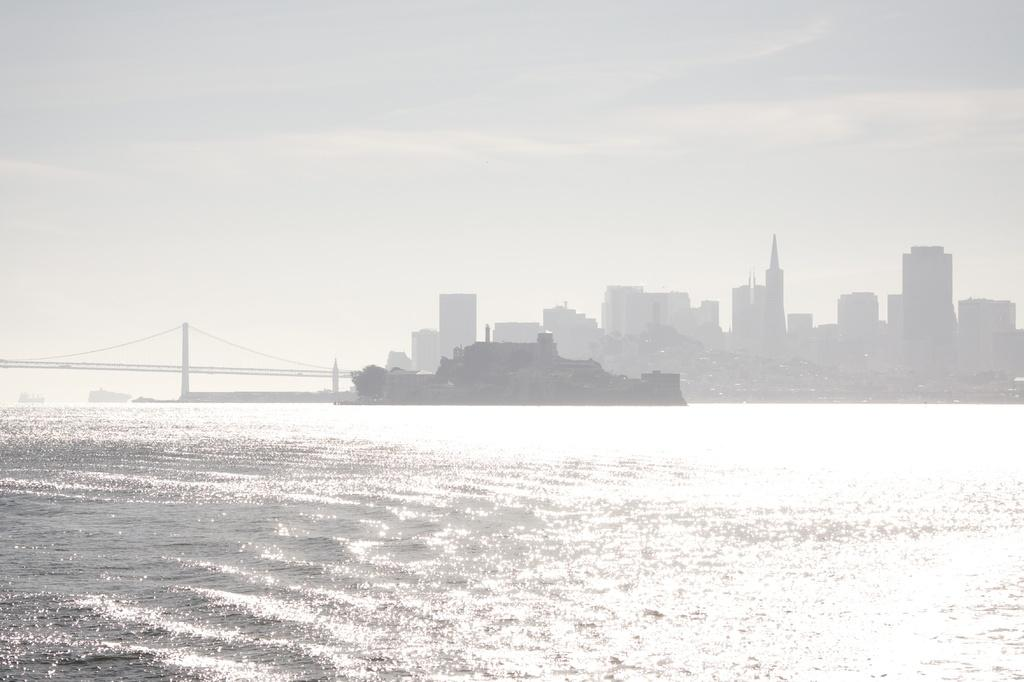What is the main subject of the image? There is a ship in the image. Where is the ship located? The ship is on the water. What can be seen in the background of the image? There is a bridge, buildings, a tree, and the sky visible in the background of the image. How many cherries are hanging from the tree in the image? There is no tree with cherries present in the image; the tree in the background has leaves, not cherries. What type of system is responsible for the ship's navigation in the image? The image does not provide information about the ship's navigation system. 